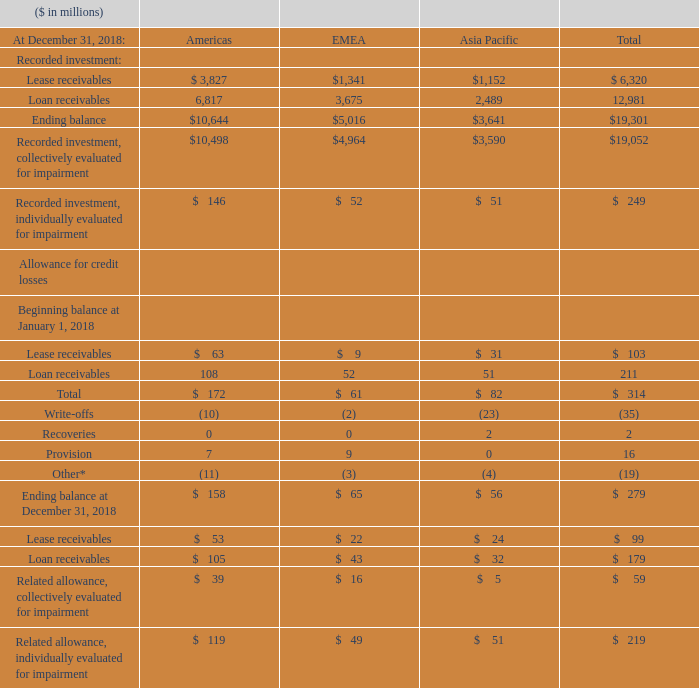Write-offs of lease receivables and loan receivables were $15 million and $20 million, respectively, for the year ended December 31, 2018. Provisions for credit losses recorded for lease receivables and loan receivables were $14 million and $2 million, respectively, for the year ended December 31, 2018.
The average recorded investment of impaired leases and loans for Americas, EMEA and Asia Pacific was $138 million, $55 million and $73 million, respectively, for the year ended December 31, 2018. Both interest income recognized, and interest income recognized on a cash basis on impaired leases and loans were immaterial for the year ended December 31, 2018.
How much was the write-offs of lease and loan receivables for December 2018? Write-offs of lease receivables and loan receivables were $15 million and $20 million, respectively, for the year ended december 31, 2018. What is the average recorded investment of impaired leases and loans for Americas, EMEA and Asia Pacific for December 2018? The average recorded investment of impaired leases and loans for americas, emea and asia pacific was $138 million, $55 million and $73 million, respectively, for the year ended december 31, 2018. How much credit losses were recorded for lease and loan receivables for December 2018? Provisions for credit losses recorded for lease receivables and loan receivables were $14 million and $2 million, respectively, for the year ended december 31, 2018. What is the average Recorded investment of Loan receivables for Americas and EMEA for December 2018?
Answer scale should be: million. (6,817+3,675) / 2
Answer: 5246. What is the average Allowance for credit losses of Lease receivables at the beginning of January 2018?
Answer scale should be: million. 103 / 3
Answer: 34.33. What is the average Recorded investment of Lease receivables for Americas and EMEA for December 2018?
Answer scale should be: million. (3,827+1,341) / 2
Answer: 2584. 